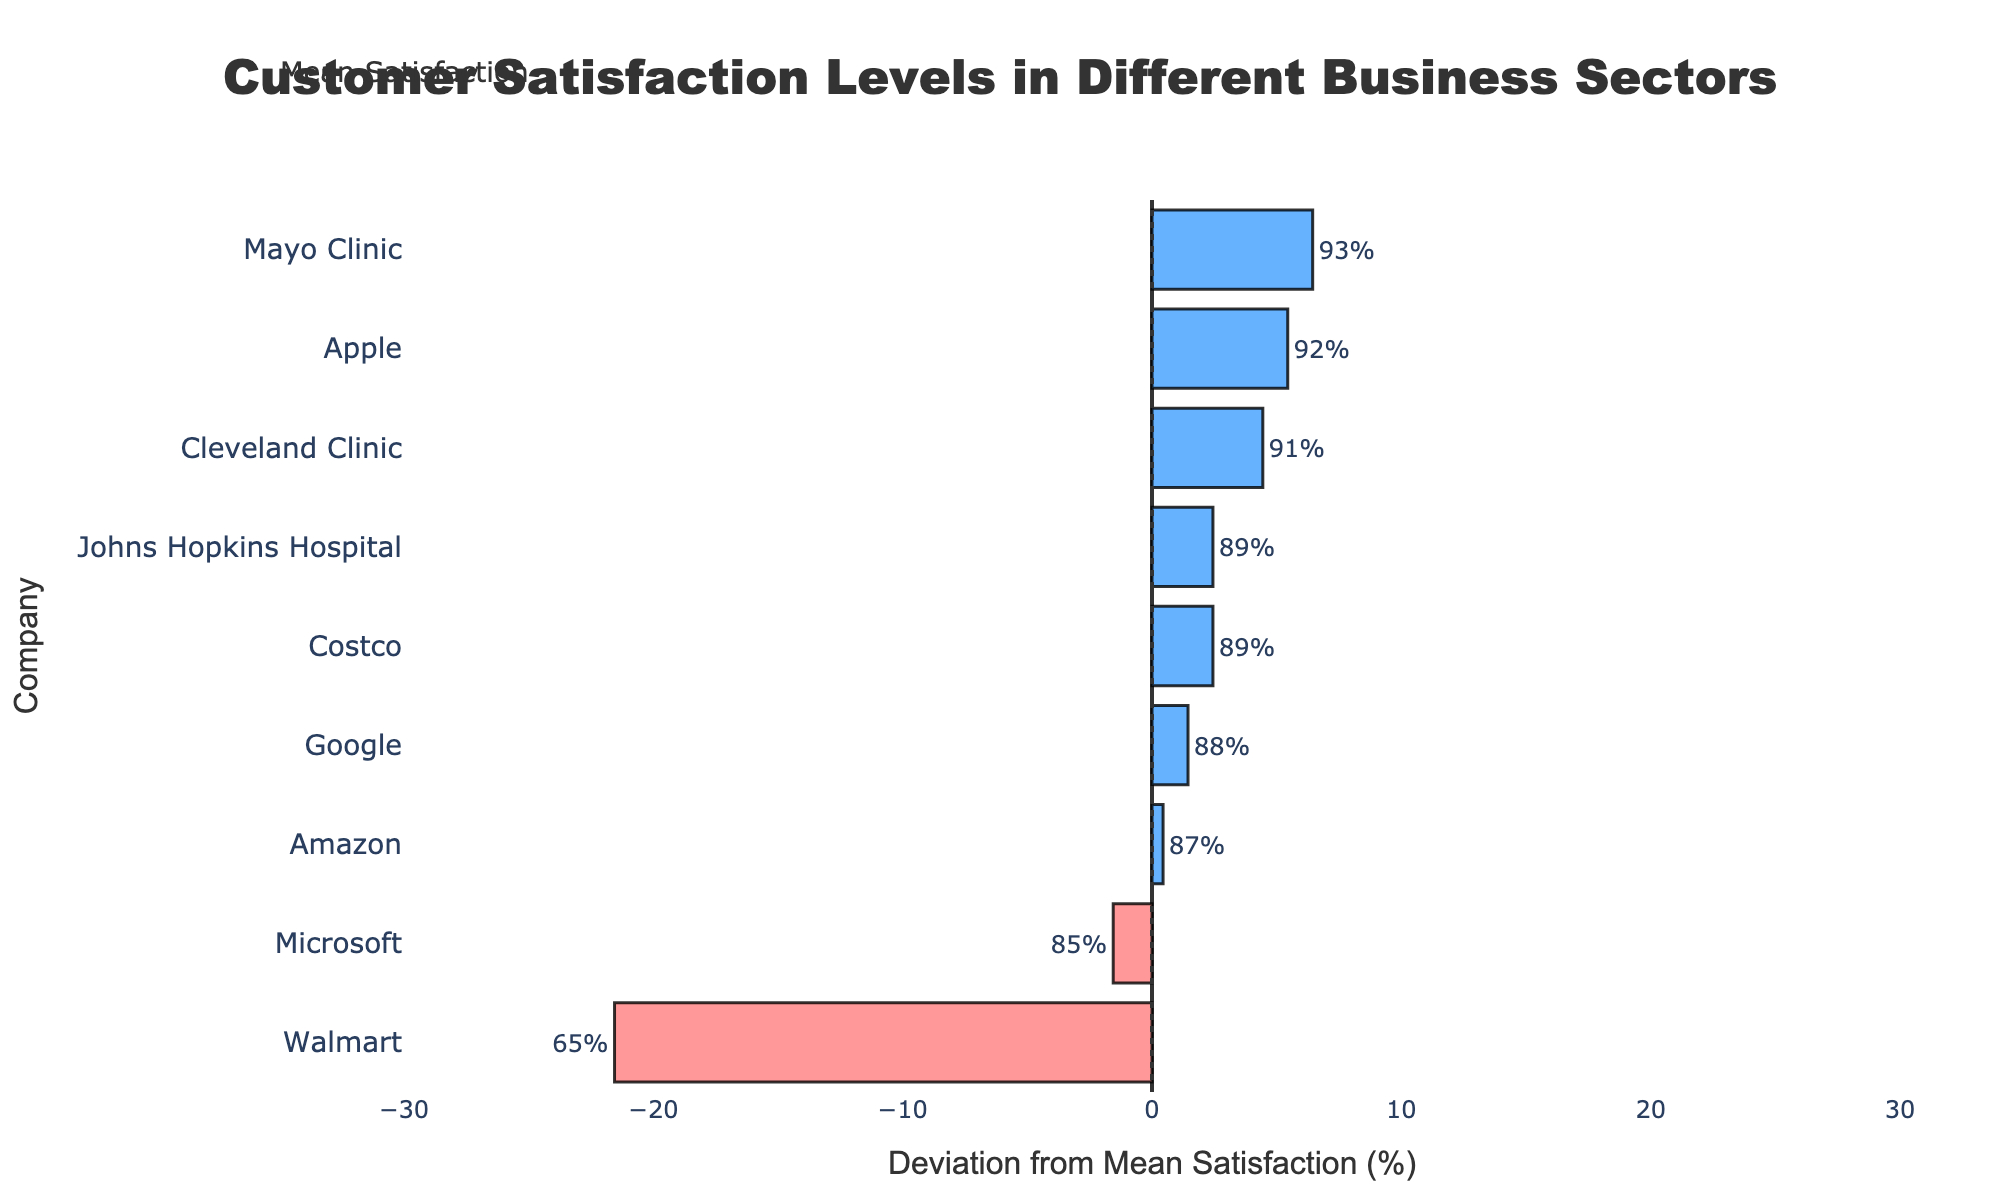What is the mean satisfaction level of all companies? Sum all the satisfaction values (87 + 65 + 89 + 92 + 85 + 88 + 91 + 93 + 89) which equals 779, then divide by the number of companies, which is 9. Mean satisfaction = 779 / 9.
Answer: 86.56% Which company has the highest customer satisfaction? The chart shows each company's satisfaction level. Mayo Clinic has the highest bar, indicating 93%.
Answer: Mayo Clinic How do Amazon and Walmart compare in terms of customer satisfaction? Amazon's satisfaction is 87%, while Walmart's is 65%, as indicated by the lengths of their respective bars.
Answer: Amazon has higher satisfaction Which companies have satisfaction below the mean satisfaction level? The companies with bars to the left of the vertical line (mean satisfaction) are those below the mean level: Walmart (65%) and Microsoft (85%).
Answer: Walmart, Microsoft What is the difference in satisfaction between the highest and lowest company? Mayo Clinic has the highest satisfaction (93%), and Walmart has the lowest (65%). The difference is 93% - 65%.
Answer: 28% How many companies are in the Retail sector, and what is their average satisfaction? There are three companies in the Retail sector: Amazon (87%), Walmart (65%), and Costco (89%). Sum their satisfaction values (87 + 65 + 89) which is 241, then divide by 3.
Answer: 80.33% What is the satisfaction range in the Technology sector? The highest satisfaction in Technology is for Apple (92%), and the lowest is Microsoft (85%). The range is 92% - 85%.
Answer: 7% What visual indicator shows which companies have above-average satisfaction levels? Companies with bars extending to the right of the vertical mean line have above-average satisfaction; these bars are in blue.
Answer: Blue bars to the right of the mean line What is the median satisfaction level among all companies? Arrange satisfaction levels in ascending order (65, 85, 87, 88, 89, 89, 91, 92, 93). The median (middle value in the sorted list) is the fifth value - 89%.
Answer: 89% How does Cleveland Clinic's customer satisfaction compare to that of Johns Hopkins Hospital? Cleveland Clinic has a satisfaction level of 91%, while Johns Hopkins Hospital has 89%, illustrated by the difference in their bar lengths.
Answer: Cleveland Clinic has higher satisfaction 